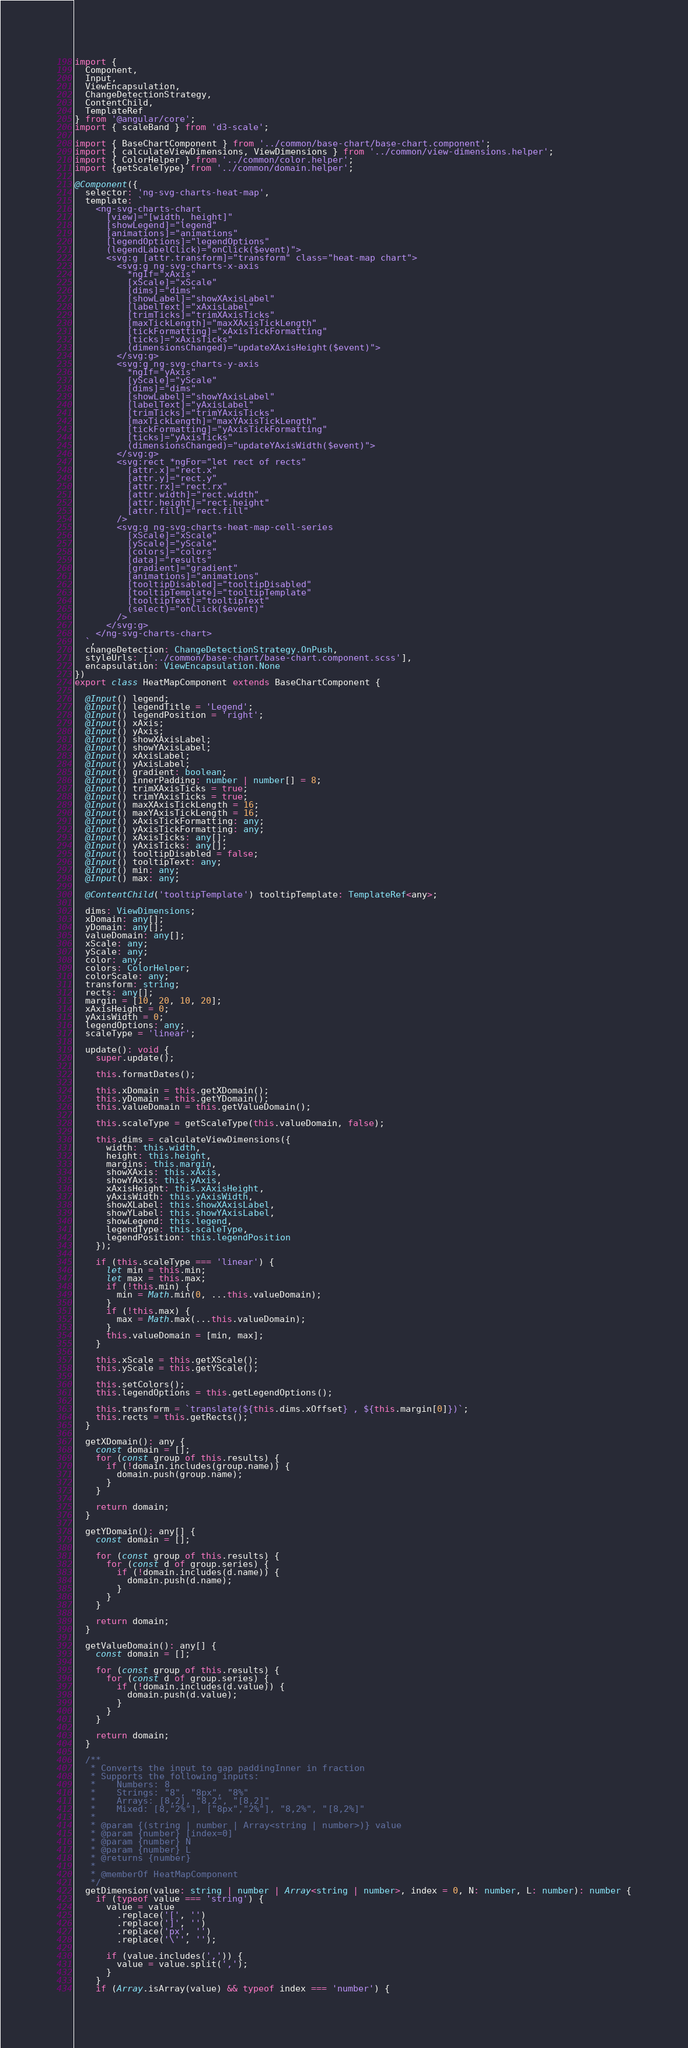<code> <loc_0><loc_0><loc_500><loc_500><_TypeScript_>import {
  Component,
  Input,
  ViewEncapsulation,
  ChangeDetectionStrategy,
  ContentChild,
  TemplateRef
} from '@angular/core';
import { scaleBand } from 'd3-scale';

import { BaseChartComponent } from '../common/base-chart/base-chart.component';
import { calculateViewDimensions, ViewDimensions } from '../common/view-dimensions.helper';
import { ColorHelper } from '../common/color.helper';
import {getScaleType} from '../common/domain.helper';

@Component({
  selector: 'ng-svg-charts-heat-map',
  template: `
    <ng-svg-charts-chart
      [view]="[width, height]"
      [showLegend]="legend"
      [animations]="animations"
      [legendOptions]="legendOptions"
      (legendLabelClick)="onClick($event)">
      <svg:g [attr.transform]="transform" class="heat-map chart">
        <svg:g ng-svg-charts-x-axis
          *ngIf="xAxis"
          [xScale]="xScale"
          [dims]="dims"
          [showLabel]="showXAxisLabel"
          [labelText]="xAxisLabel"
          [trimTicks]="trimXAxisTicks"
          [maxTickLength]="maxXAxisTickLength"
          [tickFormatting]="xAxisTickFormatting"
          [ticks]="xAxisTicks"
          (dimensionsChanged)="updateXAxisHeight($event)">
        </svg:g>
        <svg:g ng-svg-charts-y-axis
          *ngIf="yAxis"
          [yScale]="yScale"
          [dims]="dims"
          [showLabel]="showYAxisLabel"
          [labelText]="yAxisLabel"
          [trimTicks]="trimYAxisTicks"
          [maxTickLength]="maxYAxisTickLength"
          [tickFormatting]="yAxisTickFormatting"
          [ticks]="yAxisTicks"
          (dimensionsChanged)="updateYAxisWidth($event)">
        </svg:g>
        <svg:rect *ngFor="let rect of rects"
          [attr.x]="rect.x"
          [attr.y]="rect.y"
          [attr.rx]="rect.rx"
          [attr.width]="rect.width"
          [attr.height]="rect.height"
          [attr.fill]="rect.fill"
        />
        <svg:g ng-svg-charts-heat-map-cell-series
          [xScale]="xScale"
          [yScale]="yScale"
          [colors]="colors"
          [data]="results"
          [gradient]="gradient"
          [animations]="animations"
          [tooltipDisabled]="tooltipDisabled"
          [tooltipTemplate]="tooltipTemplate"
          [tooltipText]="tooltipText"
          (select)="onClick($event)"
        />
      </svg:g>
    </ng-svg-charts-chart>
  `,
  changeDetection: ChangeDetectionStrategy.OnPush,
  styleUrls: ['../common/base-chart/base-chart.component.scss'],
  encapsulation: ViewEncapsulation.None
})
export class HeatMapComponent extends BaseChartComponent {

  @Input() legend;
  @Input() legendTitle = 'Legend';
  @Input() legendPosition = 'right';
  @Input() xAxis;
  @Input() yAxis;
  @Input() showXAxisLabel;
  @Input() showYAxisLabel;
  @Input() xAxisLabel;
  @Input() yAxisLabel;
  @Input() gradient: boolean;
  @Input() innerPadding: number | number[] = 8;
  @Input() trimXAxisTicks = true;
  @Input() trimYAxisTicks = true;
  @Input() maxXAxisTickLength = 16;
  @Input() maxYAxisTickLength = 16;
  @Input() xAxisTickFormatting: any;
  @Input() yAxisTickFormatting: any;
  @Input() xAxisTicks: any[];
  @Input() yAxisTicks: any[];
  @Input() tooltipDisabled = false;
  @Input() tooltipText: any;
  @Input() min: any;
  @Input() max: any;

  @ContentChild('tooltipTemplate') tooltipTemplate: TemplateRef<any>;

  dims: ViewDimensions;
  xDomain: any[];
  yDomain: any[];
  valueDomain: any[];
  xScale: any;
  yScale: any;
  color: any;
  colors: ColorHelper;
  colorScale: any;
  transform: string;
  rects: any[];
  margin = [10, 20, 10, 20];
  xAxisHeight = 0;
  yAxisWidth = 0;
  legendOptions: any;
  scaleType = 'linear';

  update(): void {
    super.update();

    this.formatDates();

    this.xDomain = this.getXDomain();
    this.yDomain = this.getYDomain();
    this.valueDomain = this.getValueDomain();

    this.scaleType = getScaleType(this.valueDomain, false);

    this.dims = calculateViewDimensions({
      width: this.width,
      height: this.height,
      margins: this.margin,
      showXAxis: this.xAxis,
      showYAxis: this.yAxis,
      xAxisHeight: this.xAxisHeight,
      yAxisWidth: this.yAxisWidth,
      showXLabel: this.showXAxisLabel,
      showYLabel: this.showYAxisLabel,
      showLegend: this.legend,
      legendType: this.scaleType,
      legendPosition: this.legendPosition
    });

    if (this.scaleType === 'linear') {
      let min = this.min;
      let max = this.max;
      if (!this.min) {
        min = Math.min(0, ...this.valueDomain);
      }
      if (!this.max) {
        max = Math.max(...this.valueDomain);
      }
      this.valueDomain = [min, max];
    }

    this.xScale = this.getXScale();
    this.yScale = this.getYScale();

    this.setColors();
    this.legendOptions = this.getLegendOptions();

    this.transform = `translate(${this.dims.xOffset} , ${this.margin[0]})`;
    this.rects = this.getRects();
  }

  getXDomain(): any {
    const domain = [];
    for (const group of this.results) {
      if (!domain.includes(group.name)) {
        domain.push(group.name);
      }
    }

    return domain;
  }

  getYDomain(): any[] {
    const domain = [];

    for (const group of this.results) {
      for (const d of group.series) {
        if (!domain.includes(d.name)) {
          domain.push(d.name);
        }
      }
    }

    return domain;
  }

  getValueDomain(): any[] {
    const domain = [];

    for (const group of this.results) {
      for (const d of group.series) {
        if (!domain.includes(d.value)) {
          domain.push(d.value);
        }
      }
    }

    return domain;
  }

  /**
   * Converts the input to gap paddingInner in fraction
   * Supports the following inputs:
   *    Numbers: 8
   *    Strings: "8", "8px", "8%"
   *    Arrays: [8,2], "8,2", "[8,2]"
   *    Mixed: [8,"2%"], ["8px","2%"], "8,2%", "[8,2%]"
   *
   * @param {(string | number | Array<string | number>)} value
   * @param {number} [index=0]
   * @param {number} N
   * @param {number} L
   * @returns {number}
   *
   * @memberOf HeatMapComponent
   */
  getDimension(value: string | number | Array<string | number>, index = 0, N: number, L: number): number {
    if (typeof value === 'string') {
      value = value
        .replace('[', '')
        .replace(']', '')
        .replace('px', '')
        .replace('\'', '');

      if (value.includes(',')) {
        value = value.split(',');
      }
    }
    if (Array.isArray(value) && typeof index === 'number') {</code> 